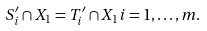<formula> <loc_0><loc_0><loc_500><loc_500>S ^ { \prime } _ { i } \cap X _ { 1 } = T ^ { \prime } _ { i } \cap X _ { 1 } i = 1 , \dots , m .</formula> 